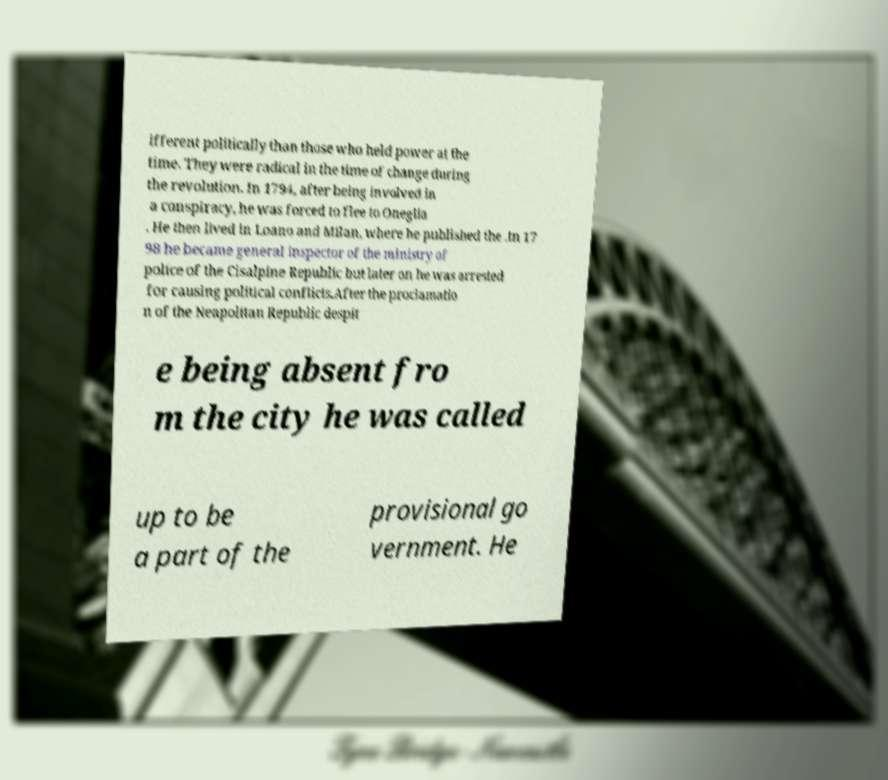There's text embedded in this image that I need extracted. Can you transcribe it verbatim? ifferent politically than those who held power at the time. They were radical in the time of change during the revolution. In 1794, after being involved in a conspiracy, he was forced to flee to Oneglia . He then lived in Loano and Milan, where he published the .In 17 98 he became general inspector of the ministry of police of the Cisalpine Republic but later on he was arrested for causing political conflicts.After the proclamatio n of the Neapolitan Republic despit e being absent fro m the city he was called up to be a part of the provisional go vernment. He 